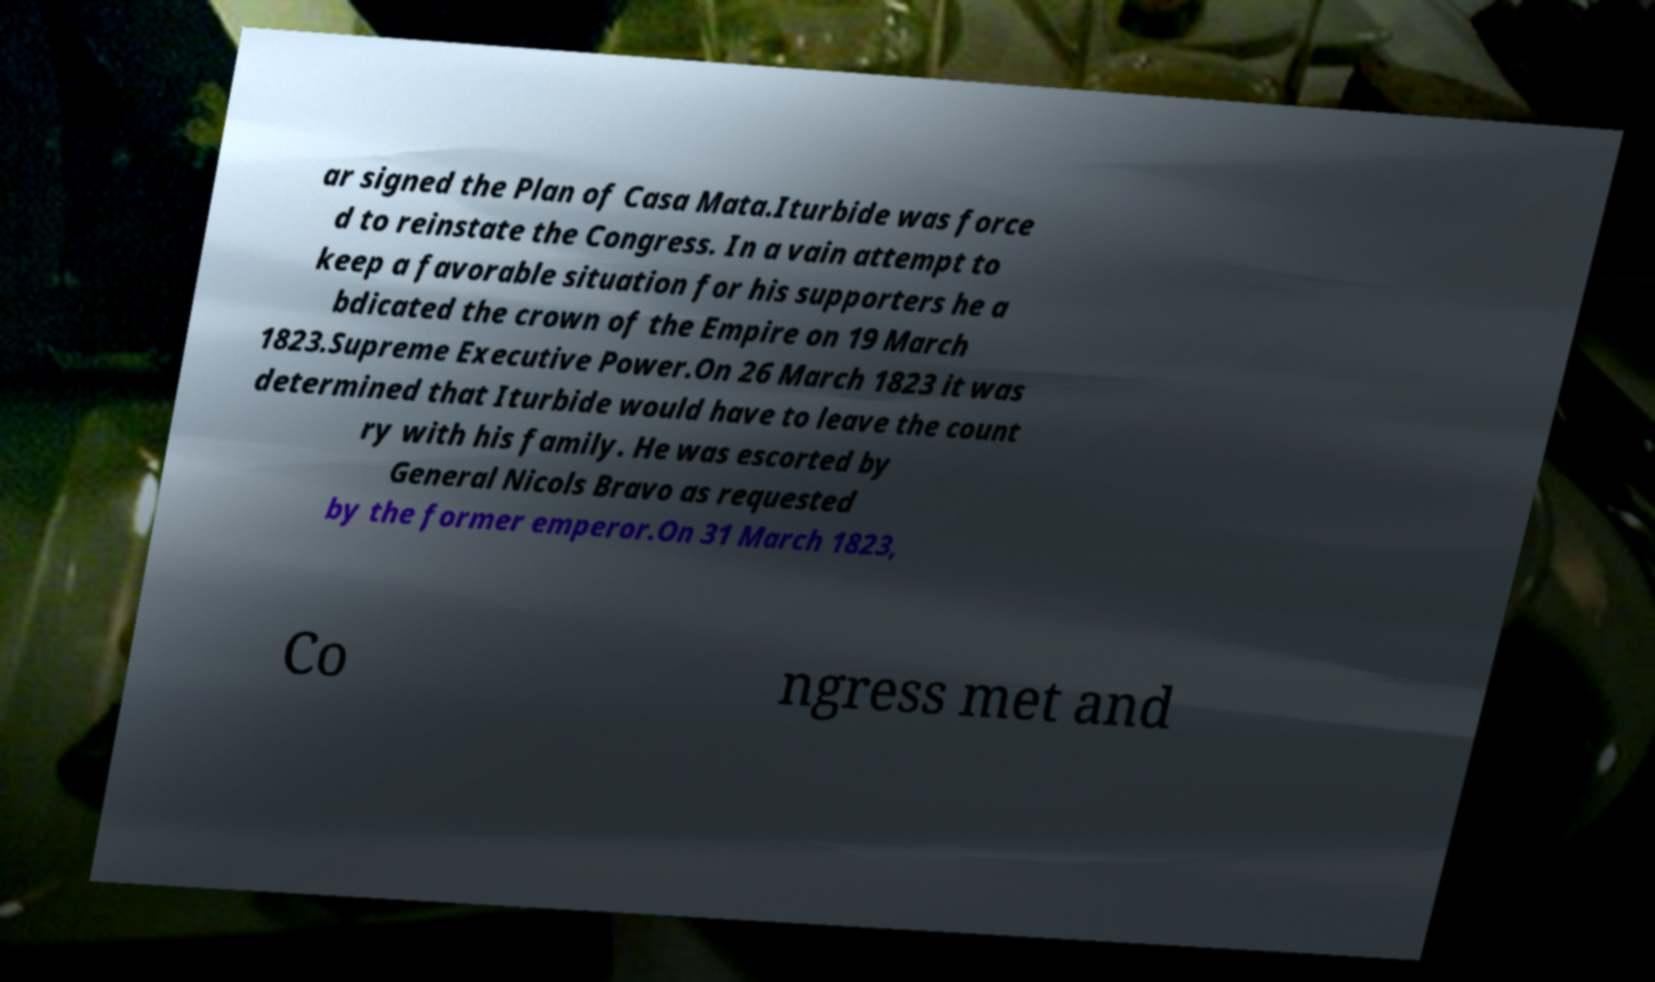I need the written content from this picture converted into text. Can you do that? ar signed the Plan of Casa Mata.Iturbide was force d to reinstate the Congress. In a vain attempt to keep a favorable situation for his supporters he a bdicated the crown of the Empire on 19 March 1823.Supreme Executive Power.On 26 March 1823 it was determined that Iturbide would have to leave the count ry with his family. He was escorted by General Nicols Bravo as requested by the former emperor.On 31 March 1823, Co ngress met and 